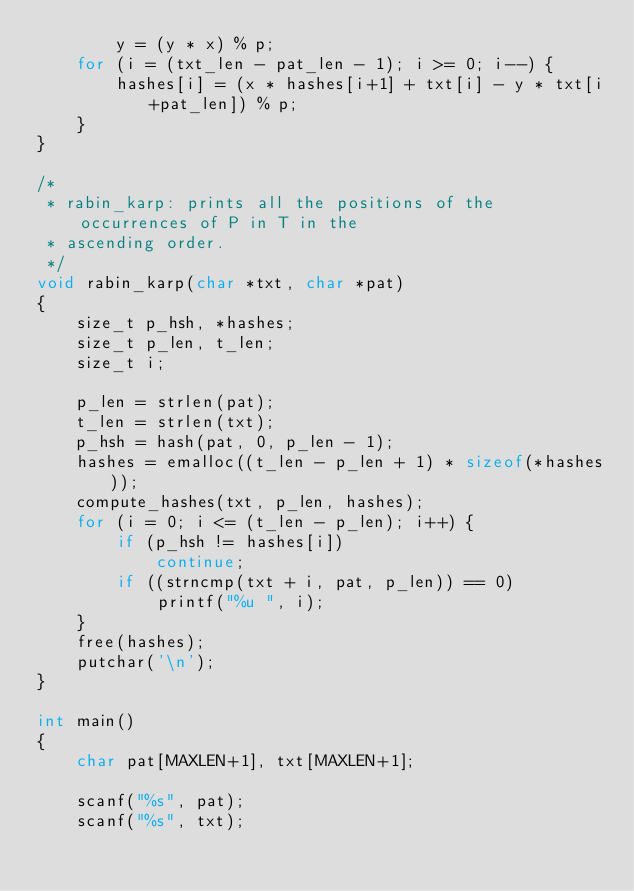Convert code to text. <code><loc_0><loc_0><loc_500><loc_500><_C_>        y = (y * x) % p;
    for (i = (txt_len - pat_len - 1); i >= 0; i--) {
        hashes[i] = (x * hashes[i+1] + txt[i] - y * txt[i+pat_len]) % p;
    }
}

/*
 * rabin_karp: prints all the positions of the occurrences of P in T in the 
 * ascending order.
 */
void rabin_karp(char *txt, char *pat)
{
    size_t p_hsh, *hashes;
    size_t p_len, t_len;
    size_t i;

    p_len = strlen(pat);
    t_len = strlen(txt);
    p_hsh = hash(pat, 0, p_len - 1);
    hashes = emalloc((t_len - p_len + 1) * sizeof(*hashes));
    compute_hashes(txt, p_len, hashes);
    for (i = 0; i <= (t_len - p_len); i++) {
        if (p_hsh != hashes[i])
            continue;
        if ((strncmp(txt + i, pat, p_len)) == 0)
            printf("%u ", i);
    }
    free(hashes);
    putchar('\n');
}

int main()
{
    char pat[MAXLEN+1], txt[MAXLEN+1];

    scanf("%s", pat);
    scanf("%s", txt);</code> 